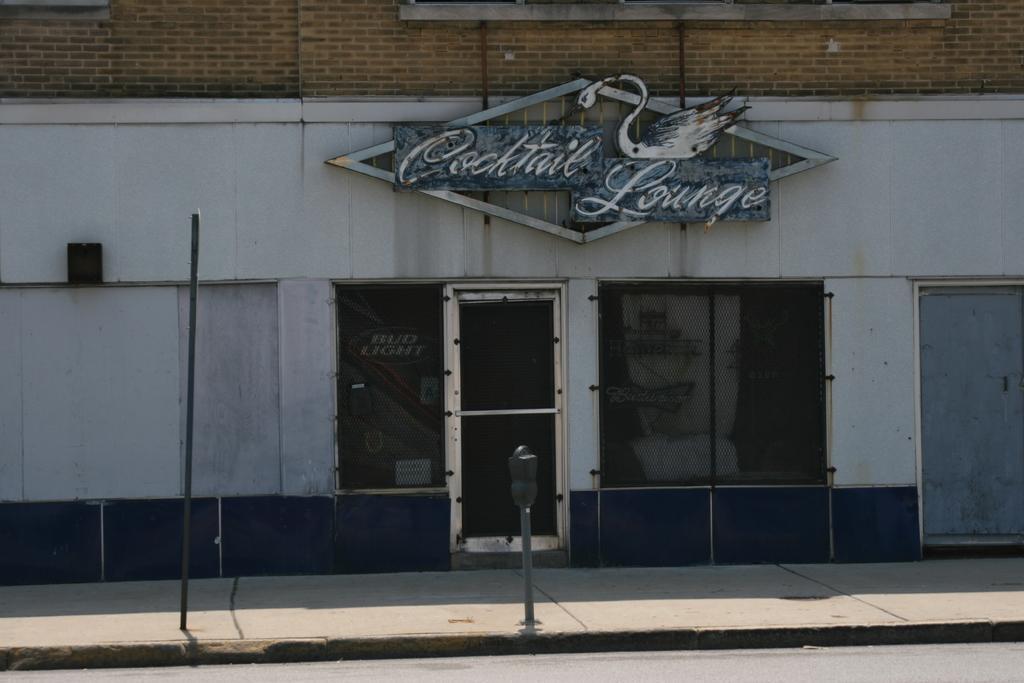How would you summarize this image in a sentence or two? In this image I can see a building with name board and door, in-front of that there are few poles. 